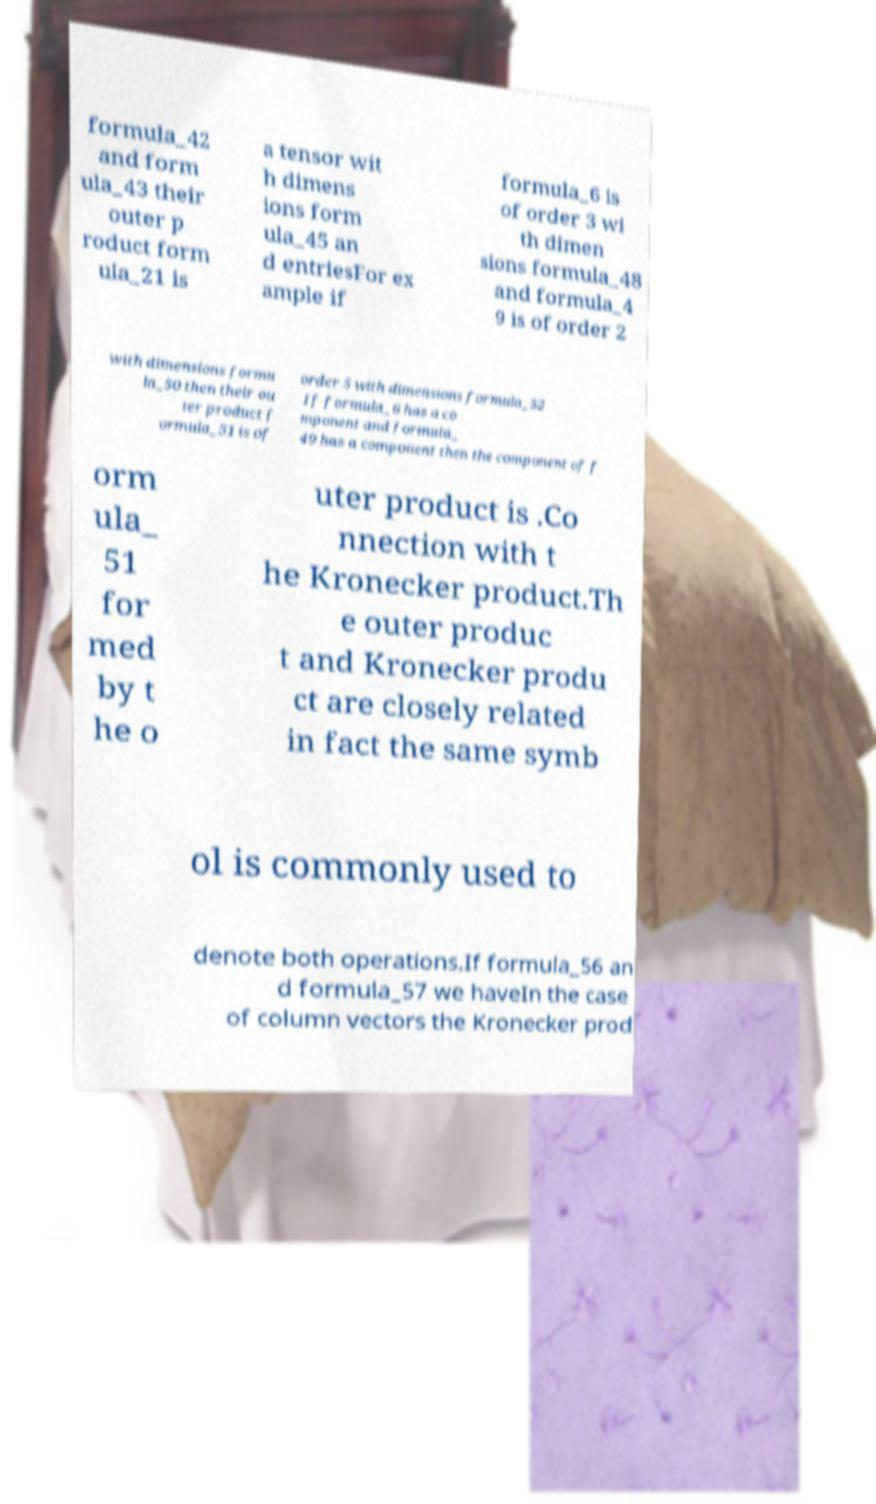Please read and relay the text visible in this image. What does it say? formula_42 and form ula_43 their outer p roduct form ula_21 is a tensor wit h dimens ions form ula_45 an d entriesFor ex ample if formula_6 is of order 3 wi th dimen sions formula_48 and formula_4 9 is of order 2 with dimensions formu la_50 then their ou ter product f ormula_51 is of order 5 with dimensions formula_52 If formula_6 has a co mponent and formula_ 49 has a component then the component of f orm ula_ 51 for med by t he o uter product is .Co nnection with t he Kronecker product.Th e outer produc t and Kronecker produ ct are closely related in fact the same symb ol is commonly used to denote both operations.If formula_56 an d formula_57 we haveIn the case of column vectors the Kronecker prod 